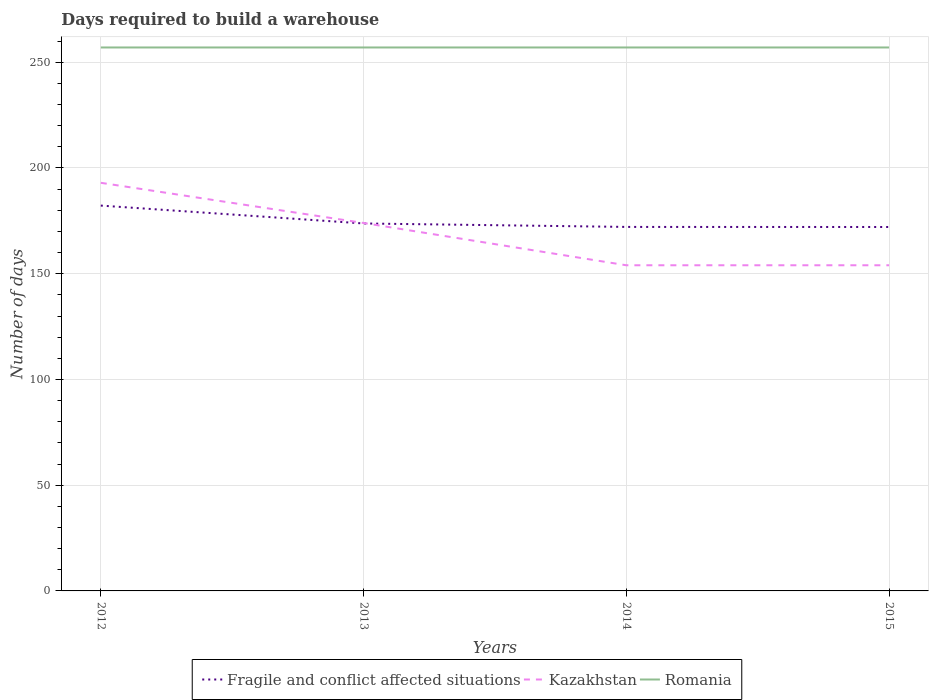Is the number of lines equal to the number of legend labels?
Your answer should be compact. Yes. Across all years, what is the maximum days required to build a warehouse in in Romania?
Your answer should be compact. 257. What is the total days required to build a warehouse in in Fragile and conflict affected situations in the graph?
Your response must be concise. 1.67. What is the difference between the highest and the second highest days required to build a warehouse in in Kazakhstan?
Provide a short and direct response. 39. Is the days required to build a warehouse in in Fragile and conflict affected situations strictly greater than the days required to build a warehouse in in Kazakhstan over the years?
Offer a terse response. No. How many lines are there?
Give a very brief answer. 3. How many years are there in the graph?
Make the answer very short. 4. Where does the legend appear in the graph?
Offer a very short reply. Bottom center. What is the title of the graph?
Keep it short and to the point. Days required to build a warehouse. Does "Antigua and Barbuda" appear as one of the legend labels in the graph?
Offer a very short reply. No. What is the label or title of the X-axis?
Keep it short and to the point. Years. What is the label or title of the Y-axis?
Your answer should be very brief. Number of days. What is the Number of days of Fragile and conflict affected situations in 2012?
Provide a succinct answer. 182.23. What is the Number of days in Kazakhstan in 2012?
Offer a terse response. 193. What is the Number of days of Romania in 2012?
Give a very brief answer. 257. What is the Number of days of Fragile and conflict affected situations in 2013?
Offer a terse response. 173.77. What is the Number of days of Kazakhstan in 2013?
Ensure brevity in your answer.  174. What is the Number of days of Romania in 2013?
Give a very brief answer. 257. What is the Number of days in Fragile and conflict affected situations in 2014?
Make the answer very short. 172.13. What is the Number of days in Kazakhstan in 2014?
Give a very brief answer. 154. What is the Number of days of Romania in 2014?
Your answer should be very brief. 257. What is the Number of days in Fragile and conflict affected situations in 2015?
Keep it short and to the point. 172.1. What is the Number of days of Kazakhstan in 2015?
Offer a very short reply. 154. What is the Number of days of Romania in 2015?
Give a very brief answer. 257. Across all years, what is the maximum Number of days in Fragile and conflict affected situations?
Keep it short and to the point. 182.23. Across all years, what is the maximum Number of days of Kazakhstan?
Provide a short and direct response. 193. Across all years, what is the maximum Number of days of Romania?
Your response must be concise. 257. Across all years, what is the minimum Number of days in Fragile and conflict affected situations?
Ensure brevity in your answer.  172.1. Across all years, what is the minimum Number of days in Kazakhstan?
Make the answer very short. 154. Across all years, what is the minimum Number of days in Romania?
Provide a succinct answer. 257. What is the total Number of days in Fragile and conflict affected situations in the graph?
Your answer should be compact. 700.23. What is the total Number of days of Kazakhstan in the graph?
Your response must be concise. 675. What is the total Number of days in Romania in the graph?
Provide a short and direct response. 1028. What is the difference between the Number of days of Fragile and conflict affected situations in 2012 and that in 2013?
Provide a succinct answer. 8.46. What is the difference between the Number of days in Kazakhstan in 2012 and that in 2013?
Ensure brevity in your answer.  19. What is the difference between the Number of days of Fragile and conflict affected situations in 2012 and that in 2014?
Provide a succinct answer. 10.09. What is the difference between the Number of days of Fragile and conflict affected situations in 2012 and that in 2015?
Your answer should be compact. 10.13. What is the difference between the Number of days of Romania in 2012 and that in 2015?
Offer a very short reply. 0. What is the difference between the Number of days of Fragile and conflict affected situations in 2013 and that in 2014?
Your answer should be very brief. 1.63. What is the difference between the Number of days of Romania in 2013 and that in 2015?
Your answer should be compact. 0. What is the difference between the Number of days in Fragile and conflict affected situations in 2014 and that in 2015?
Keep it short and to the point. 0.03. What is the difference between the Number of days of Fragile and conflict affected situations in 2012 and the Number of days of Kazakhstan in 2013?
Your response must be concise. 8.23. What is the difference between the Number of days in Fragile and conflict affected situations in 2012 and the Number of days in Romania in 2013?
Your response must be concise. -74.77. What is the difference between the Number of days of Kazakhstan in 2012 and the Number of days of Romania in 2013?
Give a very brief answer. -64. What is the difference between the Number of days in Fragile and conflict affected situations in 2012 and the Number of days in Kazakhstan in 2014?
Provide a succinct answer. 28.23. What is the difference between the Number of days of Fragile and conflict affected situations in 2012 and the Number of days of Romania in 2014?
Provide a succinct answer. -74.77. What is the difference between the Number of days in Kazakhstan in 2012 and the Number of days in Romania in 2014?
Provide a short and direct response. -64. What is the difference between the Number of days in Fragile and conflict affected situations in 2012 and the Number of days in Kazakhstan in 2015?
Offer a terse response. 28.23. What is the difference between the Number of days of Fragile and conflict affected situations in 2012 and the Number of days of Romania in 2015?
Give a very brief answer. -74.77. What is the difference between the Number of days of Kazakhstan in 2012 and the Number of days of Romania in 2015?
Offer a terse response. -64. What is the difference between the Number of days of Fragile and conflict affected situations in 2013 and the Number of days of Kazakhstan in 2014?
Your answer should be very brief. 19.77. What is the difference between the Number of days in Fragile and conflict affected situations in 2013 and the Number of days in Romania in 2014?
Ensure brevity in your answer.  -83.23. What is the difference between the Number of days in Kazakhstan in 2013 and the Number of days in Romania in 2014?
Offer a terse response. -83. What is the difference between the Number of days of Fragile and conflict affected situations in 2013 and the Number of days of Kazakhstan in 2015?
Keep it short and to the point. 19.77. What is the difference between the Number of days in Fragile and conflict affected situations in 2013 and the Number of days in Romania in 2015?
Make the answer very short. -83.23. What is the difference between the Number of days of Kazakhstan in 2013 and the Number of days of Romania in 2015?
Keep it short and to the point. -83. What is the difference between the Number of days in Fragile and conflict affected situations in 2014 and the Number of days in Kazakhstan in 2015?
Give a very brief answer. 18.13. What is the difference between the Number of days in Fragile and conflict affected situations in 2014 and the Number of days in Romania in 2015?
Your answer should be compact. -84.87. What is the difference between the Number of days of Kazakhstan in 2014 and the Number of days of Romania in 2015?
Provide a short and direct response. -103. What is the average Number of days in Fragile and conflict affected situations per year?
Offer a terse response. 175.06. What is the average Number of days of Kazakhstan per year?
Offer a very short reply. 168.75. What is the average Number of days in Romania per year?
Offer a terse response. 257. In the year 2012, what is the difference between the Number of days in Fragile and conflict affected situations and Number of days in Kazakhstan?
Provide a short and direct response. -10.77. In the year 2012, what is the difference between the Number of days of Fragile and conflict affected situations and Number of days of Romania?
Provide a succinct answer. -74.77. In the year 2012, what is the difference between the Number of days in Kazakhstan and Number of days in Romania?
Provide a succinct answer. -64. In the year 2013, what is the difference between the Number of days in Fragile and conflict affected situations and Number of days in Kazakhstan?
Your answer should be compact. -0.23. In the year 2013, what is the difference between the Number of days of Fragile and conflict affected situations and Number of days of Romania?
Keep it short and to the point. -83.23. In the year 2013, what is the difference between the Number of days in Kazakhstan and Number of days in Romania?
Provide a short and direct response. -83. In the year 2014, what is the difference between the Number of days of Fragile and conflict affected situations and Number of days of Kazakhstan?
Keep it short and to the point. 18.13. In the year 2014, what is the difference between the Number of days of Fragile and conflict affected situations and Number of days of Romania?
Your answer should be compact. -84.87. In the year 2014, what is the difference between the Number of days in Kazakhstan and Number of days in Romania?
Make the answer very short. -103. In the year 2015, what is the difference between the Number of days of Fragile and conflict affected situations and Number of days of Kazakhstan?
Your answer should be compact. 18.1. In the year 2015, what is the difference between the Number of days in Fragile and conflict affected situations and Number of days in Romania?
Your answer should be very brief. -84.9. In the year 2015, what is the difference between the Number of days of Kazakhstan and Number of days of Romania?
Provide a short and direct response. -103. What is the ratio of the Number of days of Fragile and conflict affected situations in 2012 to that in 2013?
Your answer should be very brief. 1.05. What is the ratio of the Number of days of Kazakhstan in 2012 to that in 2013?
Ensure brevity in your answer.  1.11. What is the ratio of the Number of days in Fragile and conflict affected situations in 2012 to that in 2014?
Give a very brief answer. 1.06. What is the ratio of the Number of days in Kazakhstan in 2012 to that in 2014?
Your answer should be compact. 1.25. What is the ratio of the Number of days in Fragile and conflict affected situations in 2012 to that in 2015?
Ensure brevity in your answer.  1.06. What is the ratio of the Number of days of Kazakhstan in 2012 to that in 2015?
Provide a short and direct response. 1.25. What is the ratio of the Number of days of Fragile and conflict affected situations in 2013 to that in 2014?
Make the answer very short. 1.01. What is the ratio of the Number of days of Kazakhstan in 2013 to that in 2014?
Offer a very short reply. 1.13. What is the ratio of the Number of days in Fragile and conflict affected situations in 2013 to that in 2015?
Your response must be concise. 1.01. What is the ratio of the Number of days of Kazakhstan in 2013 to that in 2015?
Provide a succinct answer. 1.13. What is the ratio of the Number of days of Romania in 2013 to that in 2015?
Ensure brevity in your answer.  1. What is the difference between the highest and the second highest Number of days of Fragile and conflict affected situations?
Your answer should be very brief. 8.46. What is the difference between the highest and the lowest Number of days in Fragile and conflict affected situations?
Provide a succinct answer. 10.13. What is the difference between the highest and the lowest Number of days in Kazakhstan?
Your response must be concise. 39. What is the difference between the highest and the lowest Number of days of Romania?
Provide a succinct answer. 0. 